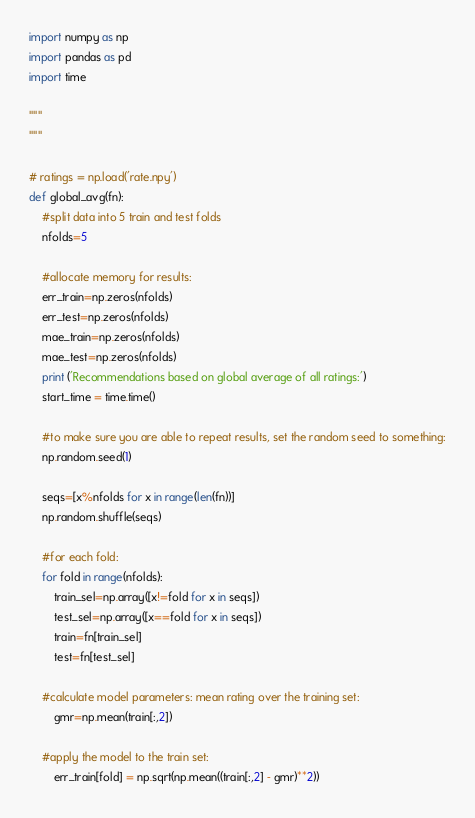<code> <loc_0><loc_0><loc_500><loc_500><_Python_>import numpy as np
import pandas as pd
import time

"""
"""

# ratings = np.load('rate.npy')
def global_avg(fn):
    #split data into 5 train and test folds
    nfolds=5

    #allocate memory for results:
    err_train=np.zeros(nfolds)
    err_test=np.zeros(nfolds)
    mae_train=np.zeros(nfolds)
    mae_test=np.zeros(nfolds)
    print ('Recommendations based on global average of all ratings:')
    start_time = time.time()

    #to make sure you are able to repeat results, set the random seed to something:
    np.random.seed(1)

    seqs=[x%nfolds for x in range(len(fn))]
    np.random.shuffle(seqs)

    #for each fold:
    for fold in range(nfolds):
        train_sel=np.array([x!=fold for x in seqs])
        test_sel=np.array([x==fold for x in seqs])
        train=fn[train_sel]
        test=fn[test_sel]

    #calculate model parameters: mean rating over the training set:
        gmr=np.mean(train[:,2])

    #apply the model to the train set:
        err_train[fold] = np.sqrt(np.mean((train[:,2] - gmr)**2))</code> 